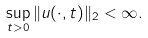Convert formula to latex. <formula><loc_0><loc_0><loc_500><loc_500>\sup _ { t > 0 } \| u ( \cdot , t ) \| _ { 2 } < \infty .</formula> 